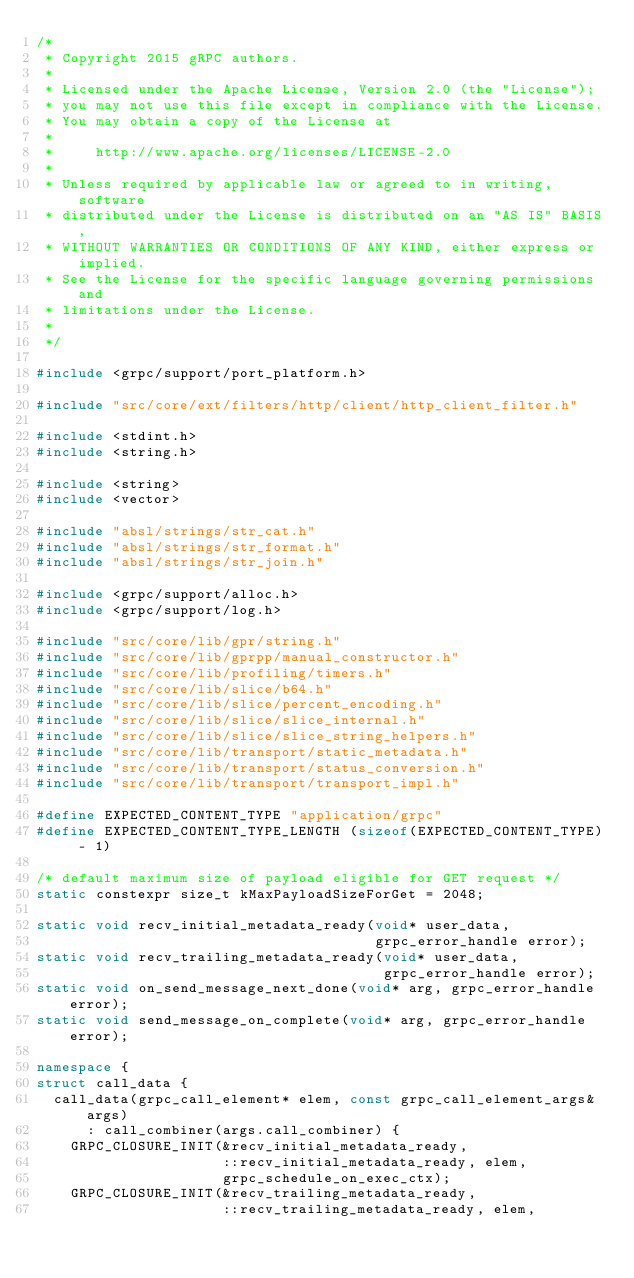<code> <loc_0><loc_0><loc_500><loc_500><_C++_>/*
 * Copyright 2015 gRPC authors.
 *
 * Licensed under the Apache License, Version 2.0 (the "License");
 * you may not use this file except in compliance with the License.
 * You may obtain a copy of the License at
 *
 *     http://www.apache.org/licenses/LICENSE-2.0
 *
 * Unless required by applicable law or agreed to in writing, software
 * distributed under the License is distributed on an "AS IS" BASIS,
 * WITHOUT WARRANTIES OR CONDITIONS OF ANY KIND, either express or implied.
 * See the License for the specific language governing permissions and
 * limitations under the License.
 *
 */

#include <grpc/support/port_platform.h>

#include "src/core/ext/filters/http/client/http_client_filter.h"

#include <stdint.h>
#include <string.h>

#include <string>
#include <vector>

#include "absl/strings/str_cat.h"
#include "absl/strings/str_format.h"
#include "absl/strings/str_join.h"

#include <grpc/support/alloc.h>
#include <grpc/support/log.h>

#include "src/core/lib/gpr/string.h"
#include "src/core/lib/gprpp/manual_constructor.h"
#include "src/core/lib/profiling/timers.h"
#include "src/core/lib/slice/b64.h"
#include "src/core/lib/slice/percent_encoding.h"
#include "src/core/lib/slice/slice_internal.h"
#include "src/core/lib/slice/slice_string_helpers.h"
#include "src/core/lib/transport/static_metadata.h"
#include "src/core/lib/transport/status_conversion.h"
#include "src/core/lib/transport/transport_impl.h"

#define EXPECTED_CONTENT_TYPE "application/grpc"
#define EXPECTED_CONTENT_TYPE_LENGTH (sizeof(EXPECTED_CONTENT_TYPE) - 1)

/* default maximum size of payload eligible for GET request */
static constexpr size_t kMaxPayloadSizeForGet = 2048;

static void recv_initial_metadata_ready(void* user_data,
                                        grpc_error_handle error);
static void recv_trailing_metadata_ready(void* user_data,
                                         grpc_error_handle error);
static void on_send_message_next_done(void* arg, grpc_error_handle error);
static void send_message_on_complete(void* arg, grpc_error_handle error);

namespace {
struct call_data {
  call_data(grpc_call_element* elem, const grpc_call_element_args& args)
      : call_combiner(args.call_combiner) {
    GRPC_CLOSURE_INIT(&recv_initial_metadata_ready,
                      ::recv_initial_metadata_ready, elem,
                      grpc_schedule_on_exec_ctx);
    GRPC_CLOSURE_INIT(&recv_trailing_metadata_ready,
                      ::recv_trailing_metadata_ready, elem,</code> 